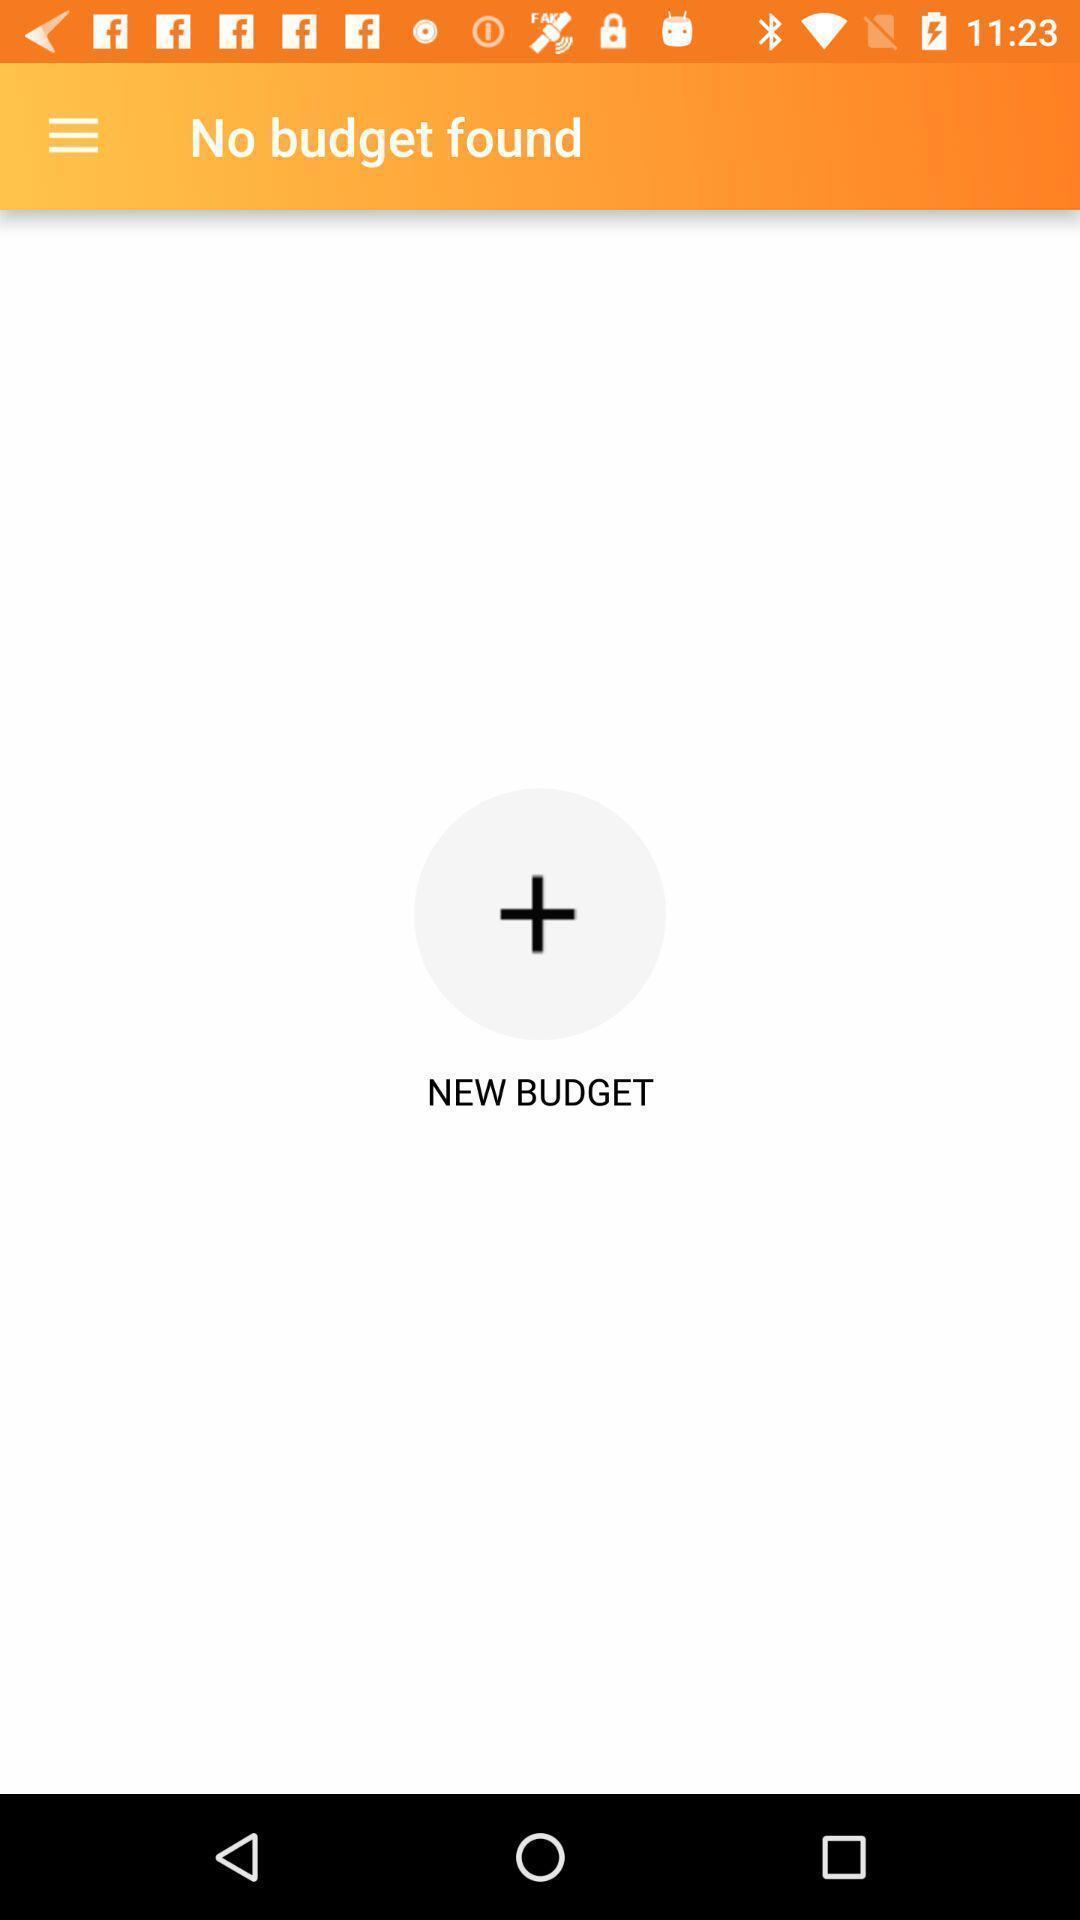Explain what's happening in this screen capture. Page showing option to add new budget. 